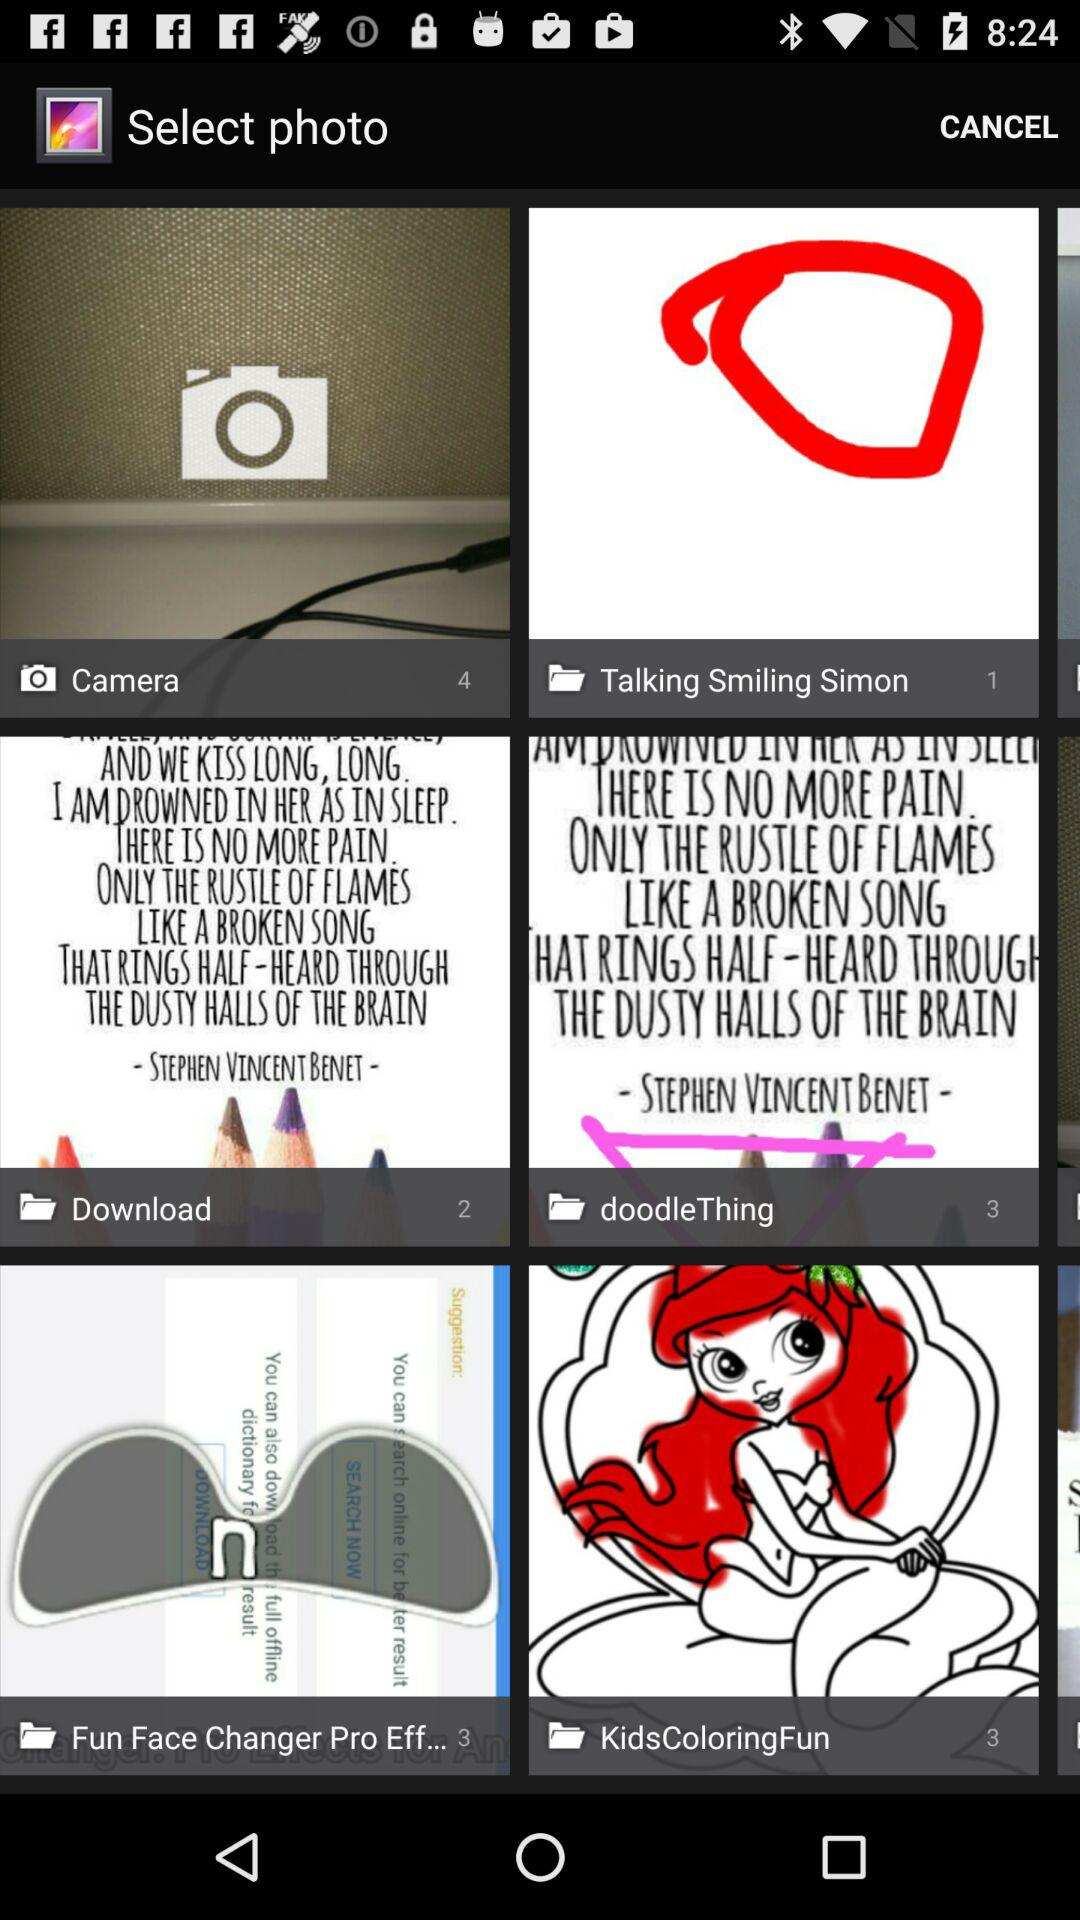How many files are there in the Doodle Thing Folder? There are 3 files in the Doodle Thing Folder. 